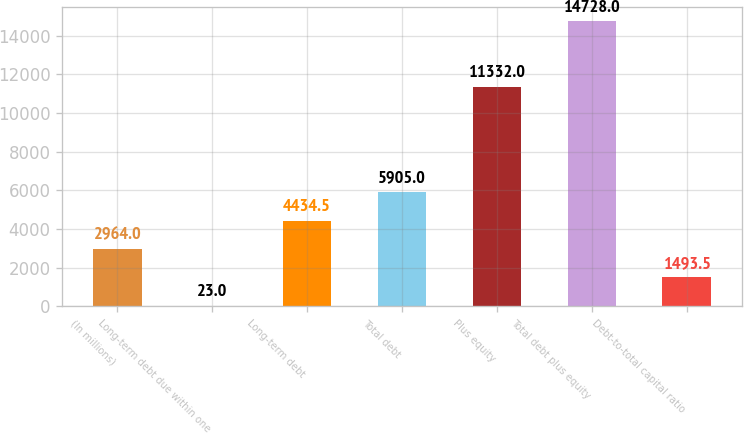Convert chart to OTSL. <chart><loc_0><loc_0><loc_500><loc_500><bar_chart><fcel>(In millions)<fcel>Long-term debt due within one<fcel>Long-term debt<fcel>Total debt<fcel>Plus equity<fcel>Total debt plus equity<fcel>Debt-to-total capital ratio<nl><fcel>2964<fcel>23<fcel>4434.5<fcel>5905<fcel>11332<fcel>14728<fcel>1493.5<nl></chart> 